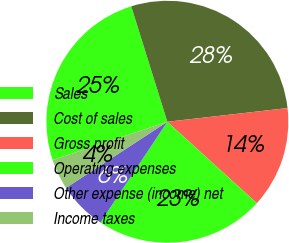Convert chart to OTSL. <chart><loc_0><loc_0><loc_500><loc_500><pie_chart><fcel>Sales<fcel>Cost of sales<fcel>Gross profit<fcel>Operating expenses<fcel>Other expense (income) net<fcel>Income taxes<nl><fcel>25.31%<fcel>28.02%<fcel>13.56%<fcel>22.59%<fcel>6.46%<fcel>4.07%<nl></chart> 